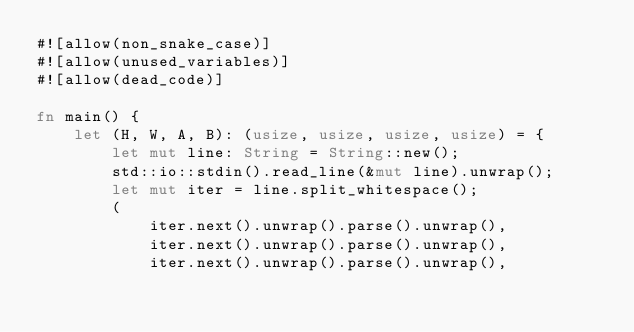Convert code to text. <code><loc_0><loc_0><loc_500><loc_500><_Rust_>#![allow(non_snake_case)]
#![allow(unused_variables)]
#![allow(dead_code)]

fn main() {
    let (H, W, A, B): (usize, usize, usize, usize) = {
        let mut line: String = String::new();
        std::io::stdin().read_line(&mut line).unwrap();
        let mut iter = line.split_whitespace();
        (
            iter.next().unwrap().parse().unwrap(),
            iter.next().unwrap().parse().unwrap(),
            iter.next().unwrap().parse().unwrap(),</code> 